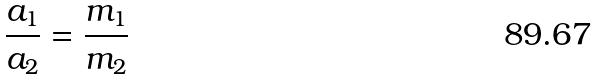Convert formula to latex. <formula><loc_0><loc_0><loc_500><loc_500>\frac { a _ { 1 } } { a _ { 2 } } = \frac { m _ { 1 } } { m _ { 2 } }</formula> 